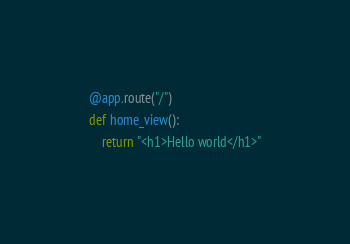<code> <loc_0><loc_0><loc_500><loc_500><_Python_>
@app.route("/")
def home_view():
    return "<h1>Hello world</h1>"
</code> 